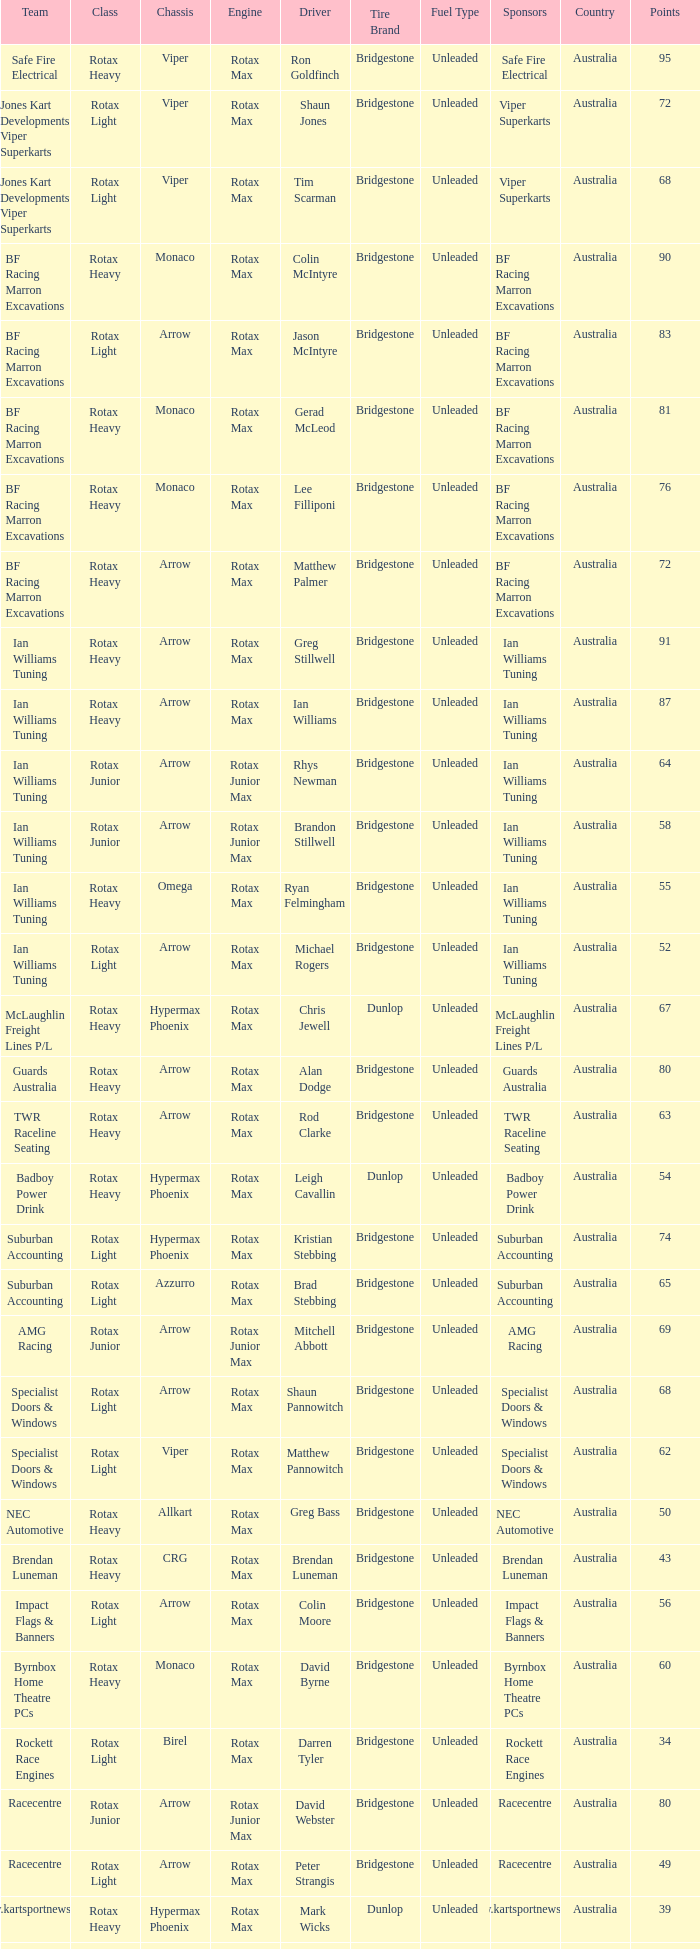Which team does Colin Moore drive for? Impact Flags & Banners. 